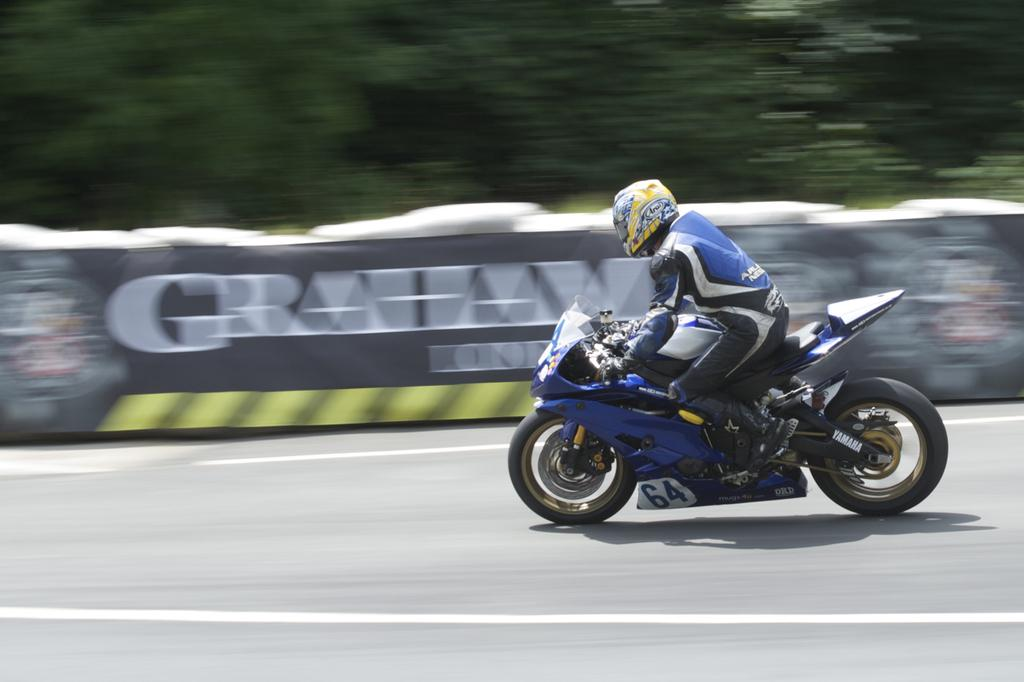Who is the main subject in the image? There is a man in the image. What is the man doing in the image? The man is riding a bike. What is the man wearing in the image? The man is wearing a blue dress. What color is the bike the man is riding? The bike is in blue color. Can you hear the frogs talking to each other in the image? There are no frogs present in the image, so it is not possible to hear them talking. 